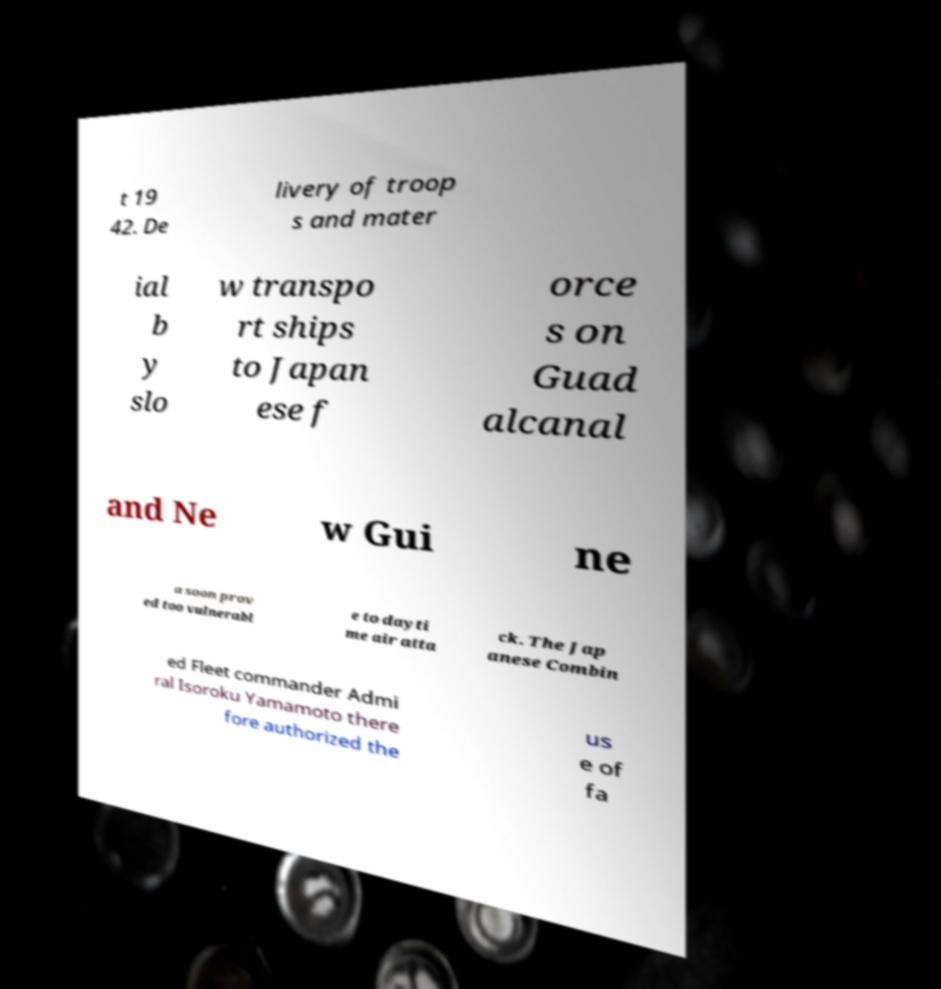Please read and relay the text visible in this image. What does it say? t 19 42. De livery of troop s and mater ial b y slo w transpo rt ships to Japan ese f orce s on Guad alcanal and Ne w Gui ne a soon prov ed too vulnerabl e to dayti me air atta ck. The Jap anese Combin ed Fleet commander Admi ral Isoroku Yamamoto there fore authorized the us e of fa 